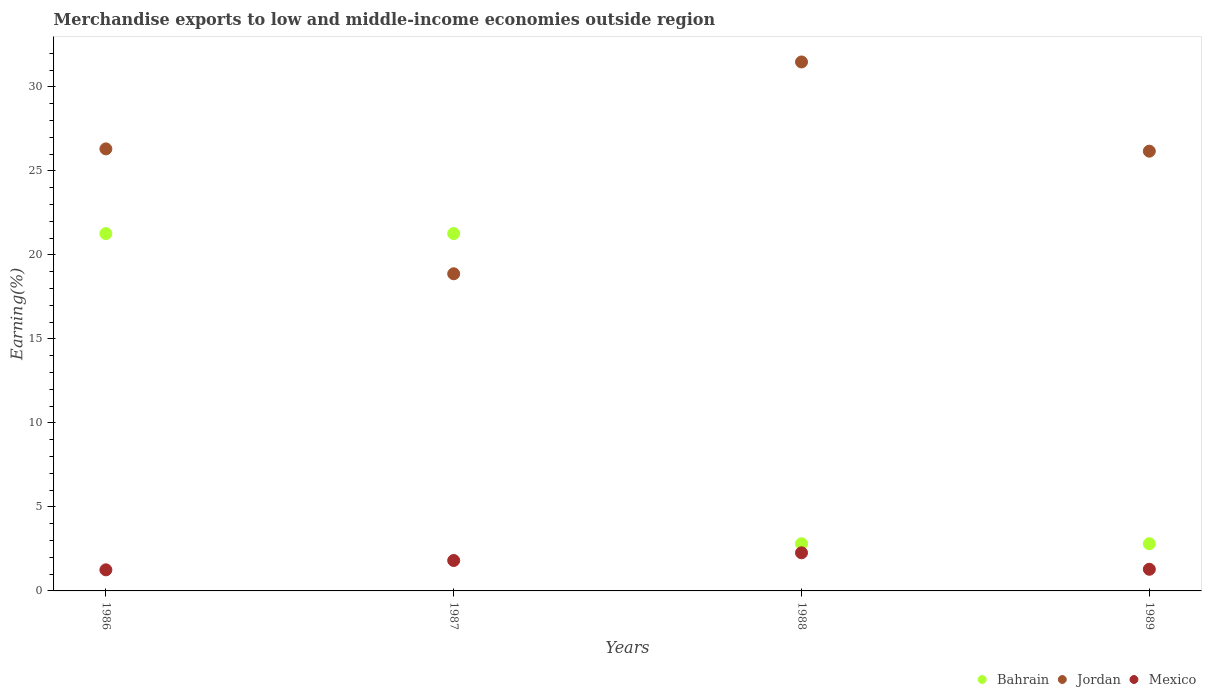Is the number of dotlines equal to the number of legend labels?
Keep it short and to the point. Yes. What is the percentage of amount earned from merchandise exports in Mexico in 1986?
Your response must be concise. 1.25. Across all years, what is the maximum percentage of amount earned from merchandise exports in Jordan?
Ensure brevity in your answer.  31.48. Across all years, what is the minimum percentage of amount earned from merchandise exports in Bahrain?
Offer a terse response. 2.81. In which year was the percentage of amount earned from merchandise exports in Jordan maximum?
Ensure brevity in your answer.  1988. What is the total percentage of amount earned from merchandise exports in Bahrain in the graph?
Provide a succinct answer. 48.15. What is the difference between the percentage of amount earned from merchandise exports in Jordan in 1986 and that in 1988?
Offer a terse response. -5.17. What is the difference between the percentage of amount earned from merchandise exports in Mexico in 1988 and the percentage of amount earned from merchandise exports in Bahrain in 1986?
Offer a terse response. -19. What is the average percentage of amount earned from merchandise exports in Bahrain per year?
Your answer should be very brief. 12.04. In the year 1986, what is the difference between the percentage of amount earned from merchandise exports in Mexico and percentage of amount earned from merchandise exports in Jordan?
Provide a succinct answer. -25.05. In how many years, is the percentage of amount earned from merchandise exports in Bahrain greater than 1 %?
Give a very brief answer. 4. What is the ratio of the percentage of amount earned from merchandise exports in Mexico in 1987 to that in 1989?
Offer a very short reply. 1.41. Is the percentage of amount earned from merchandise exports in Jordan in 1987 less than that in 1988?
Ensure brevity in your answer.  Yes. Is the difference between the percentage of amount earned from merchandise exports in Mexico in 1986 and 1987 greater than the difference between the percentage of amount earned from merchandise exports in Jordan in 1986 and 1987?
Ensure brevity in your answer.  No. What is the difference between the highest and the second highest percentage of amount earned from merchandise exports in Bahrain?
Offer a terse response. 2.4712996093967377e-9. What is the difference between the highest and the lowest percentage of amount earned from merchandise exports in Jordan?
Keep it short and to the point. 12.61. Is the sum of the percentage of amount earned from merchandise exports in Bahrain in 1986 and 1987 greater than the maximum percentage of amount earned from merchandise exports in Jordan across all years?
Your answer should be compact. Yes. Is it the case that in every year, the sum of the percentage of amount earned from merchandise exports in Jordan and percentage of amount earned from merchandise exports in Bahrain  is greater than the percentage of amount earned from merchandise exports in Mexico?
Your answer should be very brief. Yes. How many dotlines are there?
Provide a succinct answer. 3. How many years are there in the graph?
Give a very brief answer. 4. What is the difference between two consecutive major ticks on the Y-axis?
Offer a terse response. 5. Are the values on the major ticks of Y-axis written in scientific E-notation?
Give a very brief answer. No. Does the graph contain any zero values?
Make the answer very short. No. Does the graph contain grids?
Keep it short and to the point. No. How are the legend labels stacked?
Make the answer very short. Horizontal. What is the title of the graph?
Provide a short and direct response. Merchandise exports to low and middle-income economies outside region. Does "Aruba" appear as one of the legend labels in the graph?
Your answer should be very brief. No. What is the label or title of the X-axis?
Provide a succinct answer. Years. What is the label or title of the Y-axis?
Your response must be concise. Earning(%). What is the Earning(%) of Bahrain in 1986?
Your answer should be very brief. 21.27. What is the Earning(%) of Jordan in 1986?
Ensure brevity in your answer.  26.31. What is the Earning(%) in Mexico in 1986?
Give a very brief answer. 1.25. What is the Earning(%) of Bahrain in 1987?
Make the answer very short. 21.27. What is the Earning(%) of Jordan in 1987?
Make the answer very short. 18.87. What is the Earning(%) in Mexico in 1987?
Ensure brevity in your answer.  1.81. What is the Earning(%) in Bahrain in 1988?
Your answer should be compact. 2.81. What is the Earning(%) of Jordan in 1988?
Offer a terse response. 31.48. What is the Earning(%) in Mexico in 1988?
Offer a terse response. 2.27. What is the Earning(%) of Bahrain in 1989?
Give a very brief answer. 2.81. What is the Earning(%) of Jordan in 1989?
Your answer should be compact. 26.17. What is the Earning(%) of Mexico in 1989?
Keep it short and to the point. 1.29. Across all years, what is the maximum Earning(%) of Bahrain?
Provide a short and direct response. 21.27. Across all years, what is the maximum Earning(%) of Jordan?
Your answer should be compact. 31.48. Across all years, what is the maximum Earning(%) of Mexico?
Offer a terse response. 2.27. Across all years, what is the minimum Earning(%) in Bahrain?
Offer a terse response. 2.81. Across all years, what is the minimum Earning(%) in Jordan?
Your answer should be very brief. 18.87. Across all years, what is the minimum Earning(%) of Mexico?
Keep it short and to the point. 1.25. What is the total Earning(%) in Bahrain in the graph?
Your response must be concise. 48.15. What is the total Earning(%) of Jordan in the graph?
Your response must be concise. 102.83. What is the total Earning(%) in Mexico in the graph?
Make the answer very short. 6.62. What is the difference between the Earning(%) in Bahrain in 1986 and that in 1987?
Keep it short and to the point. 0. What is the difference between the Earning(%) in Jordan in 1986 and that in 1987?
Give a very brief answer. 7.43. What is the difference between the Earning(%) of Mexico in 1986 and that in 1987?
Your answer should be very brief. -0.56. What is the difference between the Earning(%) in Bahrain in 1986 and that in 1988?
Make the answer very short. 18.46. What is the difference between the Earning(%) of Jordan in 1986 and that in 1988?
Your response must be concise. -5.17. What is the difference between the Earning(%) in Mexico in 1986 and that in 1988?
Give a very brief answer. -1.01. What is the difference between the Earning(%) of Bahrain in 1986 and that in 1989?
Make the answer very short. 18.46. What is the difference between the Earning(%) in Jordan in 1986 and that in 1989?
Keep it short and to the point. 0.14. What is the difference between the Earning(%) of Mexico in 1986 and that in 1989?
Provide a short and direct response. -0.03. What is the difference between the Earning(%) of Bahrain in 1987 and that in 1988?
Your answer should be compact. 18.46. What is the difference between the Earning(%) of Jordan in 1987 and that in 1988?
Ensure brevity in your answer.  -12.61. What is the difference between the Earning(%) in Mexico in 1987 and that in 1988?
Keep it short and to the point. -0.46. What is the difference between the Earning(%) in Bahrain in 1987 and that in 1989?
Provide a succinct answer. 18.46. What is the difference between the Earning(%) in Jordan in 1987 and that in 1989?
Offer a very short reply. -7.3. What is the difference between the Earning(%) in Mexico in 1987 and that in 1989?
Make the answer very short. 0.52. What is the difference between the Earning(%) in Bahrain in 1988 and that in 1989?
Offer a very short reply. -0. What is the difference between the Earning(%) in Jordan in 1988 and that in 1989?
Provide a succinct answer. 5.31. What is the difference between the Earning(%) in Mexico in 1988 and that in 1989?
Ensure brevity in your answer.  0.98. What is the difference between the Earning(%) in Bahrain in 1986 and the Earning(%) in Jordan in 1987?
Make the answer very short. 2.39. What is the difference between the Earning(%) in Bahrain in 1986 and the Earning(%) in Mexico in 1987?
Ensure brevity in your answer.  19.46. What is the difference between the Earning(%) in Jordan in 1986 and the Earning(%) in Mexico in 1987?
Your response must be concise. 24.5. What is the difference between the Earning(%) in Bahrain in 1986 and the Earning(%) in Jordan in 1988?
Your response must be concise. -10.21. What is the difference between the Earning(%) of Bahrain in 1986 and the Earning(%) of Mexico in 1988?
Your answer should be very brief. 19. What is the difference between the Earning(%) of Jordan in 1986 and the Earning(%) of Mexico in 1988?
Your answer should be very brief. 24.04. What is the difference between the Earning(%) of Bahrain in 1986 and the Earning(%) of Jordan in 1989?
Offer a very short reply. -4.9. What is the difference between the Earning(%) in Bahrain in 1986 and the Earning(%) in Mexico in 1989?
Your answer should be compact. 19.98. What is the difference between the Earning(%) of Jordan in 1986 and the Earning(%) of Mexico in 1989?
Offer a terse response. 25.02. What is the difference between the Earning(%) in Bahrain in 1987 and the Earning(%) in Jordan in 1988?
Provide a succinct answer. -10.21. What is the difference between the Earning(%) in Bahrain in 1987 and the Earning(%) in Mexico in 1988?
Provide a succinct answer. 19. What is the difference between the Earning(%) of Jordan in 1987 and the Earning(%) of Mexico in 1988?
Your response must be concise. 16.61. What is the difference between the Earning(%) in Bahrain in 1987 and the Earning(%) in Jordan in 1989?
Offer a very short reply. -4.9. What is the difference between the Earning(%) in Bahrain in 1987 and the Earning(%) in Mexico in 1989?
Offer a very short reply. 19.98. What is the difference between the Earning(%) of Jordan in 1987 and the Earning(%) of Mexico in 1989?
Your answer should be very brief. 17.59. What is the difference between the Earning(%) in Bahrain in 1988 and the Earning(%) in Jordan in 1989?
Offer a very short reply. -23.36. What is the difference between the Earning(%) in Bahrain in 1988 and the Earning(%) in Mexico in 1989?
Make the answer very short. 1.52. What is the difference between the Earning(%) of Jordan in 1988 and the Earning(%) of Mexico in 1989?
Make the answer very short. 30.19. What is the average Earning(%) of Bahrain per year?
Your response must be concise. 12.04. What is the average Earning(%) in Jordan per year?
Offer a very short reply. 25.71. What is the average Earning(%) in Mexico per year?
Your answer should be very brief. 1.66. In the year 1986, what is the difference between the Earning(%) in Bahrain and Earning(%) in Jordan?
Your answer should be compact. -5.04. In the year 1986, what is the difference between the Earning(%) in Bahrain and Earning(%) in Mexico?
Offer a terse response. 20.01. In the year 1986, what is the difference between the Earning(%) of Jordan and Earning(%) of Mexico?
Your answer should be compact. 25.05. In the year 1987, what is the difference between the Earning(%) in Bahrain and Earning(%) in Jordan?
Provide a succinct answer. 2.39. In the year 1987, what is the difference between the Earning(%) of Bahrain and Earning(%) of Mexico?
Make the answer very short. 19.46. In the year 1987, what is the difference between the Earning(%) in Jordan and Earning(%) in Mexico?
Offer a terse response. 17.06. In the year 1988, what is the difference between the Earning(%) in Bahrain and Earning(%) in Jordan?
Keep it short and to the point. -28.67. In the year 1988, what is the difference between the Earning(%) in Bahrain and Earning(%) in Mexico?
Give a very brief answer. 0.54. In the year 1988, what is the difference between the Earning(%) of Jordan and Earning(%) of Mexico?
Make the answer very short. 29.21. In the year 1989, what is the difference between the Earning(%) of Bahrain and Earning(%) of Jordan?
Make the answer very short. -23.36. In the year 1989, what is the difference between the Earning(%) in Bahrain and Earning(%) in Mexico?
Your answer should be compact. 1.52. In the year 1989, what is the difference between the Earning(%) of Jordan and Earning(%) of Mexico?
Give a very brief answer. 24.88. What is the ratio of the Earning(%) of Bahrain in 1986 to that in 1987?
Provide a short and direct response. 1. What is the ratio of the Earning(%) in Jordan in 1986 to that in 1987?
Keep it short and to the point. 1.39. What is the ratio of the Earning(%) of Mexico in 1986 to that in 1987?
Provide a succinct answer. 0.69. What is the ratio of the Earning(%) of Bahrain in 1986 to that in 1988?
Your response must be concise. 7.57. What is the ratio of the Earning(%) of Jordan in 1986 to that in 1988?
Provide a short and direct response. 0.84. What is the ratio of the Earning(%) of Mexico in 1986 to that in 1988?
Offer a terse response. 0.55. What is the ratio of the Earning(%) of Bahrain in 1986 to that in 1989?
Keep it short and to the point. 7.57. What is the ratio of the Earning(%) in Jordan in 1986 to that in 1989?
Make the answer very short. 1.01. What is the ratio of the Earning(%) in Mexico in 1986 to that in 1989?
Provide a short and direct response. 0.97. What is the ratio of the Earning(%) in Bahrain in 1987 to that in 1988?
Keep it short and to the point. 7.57. What is the ratio of the Earning(%) of Jordan in 1987 to that in 1988?
Your answer should be very brief. 0.6. What is the ratio of the Earning(%) in Mexico in 1987 to that in 1988?
Offer a terse response. 0.8. What is the ratio of the Earning(%) of Bahrain in 1987 to that in 1989?
Offer a terse response. 7.57. What is the ratio of the Earning(%) of Jordan in 1987 to that in 1989?
Your response must be concise. 0.72. What is the ratio of the Earning(%) in Mexico in 1987 to that in 1989?
Give a very brief answer. 1.41. What is the ratio of the Earning(%) of Jordan in 1988 to that in 1989?
Your response must be concise. 1.2. What is the ratio of the Earning(%) of Mexico in 1988 to that in 1989?
Offer a very short reply. 1.76. What is the difference between the highest and the second highest Earning(%) of Jordan?
Give a very brief answer. 5.17. What is the difference between the highest and the second highest Earning(%) in Mexico?
Ensure brevity in your answer.  0.46. What is the difference between the highest and the lowest Earning(%) of Bahrain?
Your answer should be very brief. 18.46. What is the difference between the highest and the lowest Earning(%) of Jordan?
Offer a very short reply. 12.61. 